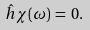Convert formula to latex. <formula><loc_0><loc_0><loc_500><loc_500>\hat { h } \chi ( \omega ) \, = \, 0 . \\</formula> 